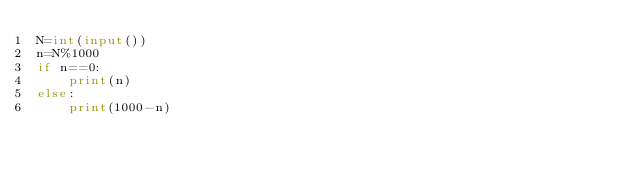Convert code to text. <code><loc_0><loc_0><loc_500><loc_500><_Python_>N=int(input())
n=N%1000
if n==0:
    print(n)
else:
    print(1000-n)</code> 